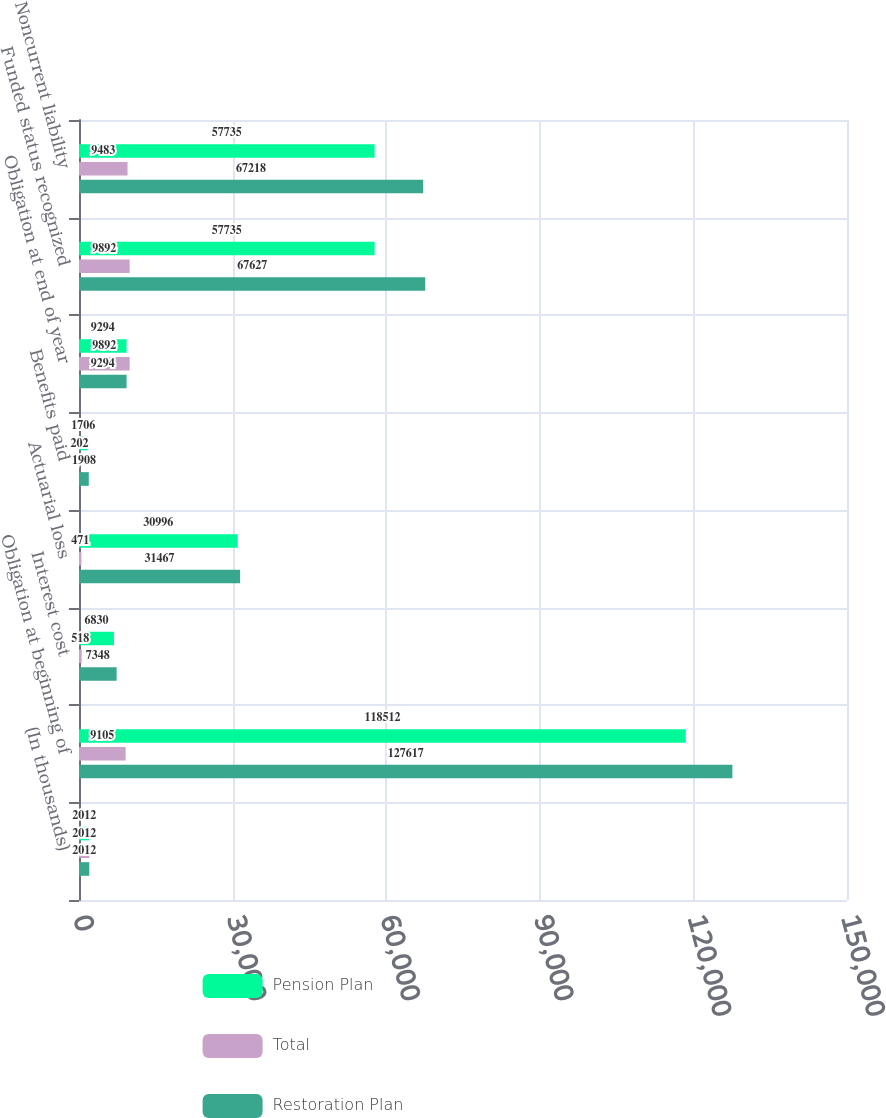Convert chart. <chart><loc_0><loc_0><loc_500><loc_500><stacked_bar_chart><ecel><fcel>(In thousands)<fcel>Obligation at beginning of<fcel>Interest cost<fcel>Actuarial loss<fcel>Benefits paid<fcel>Obligation at end of year<fcel>Funded status recognized<fcel>Noncurrent liability<nl><fcel>Pension Plan<fcel>2012<fcel>118512<fcel>6830<fcel>30996<fcel>1706<fcel>9294<fcel>57735<fcel>57735<nl><fcel>Total<fcel>2012<fcel>9105<fcel>518<fcel>471<fcel>202<fcel>9892<fcel>9892<fcel>9483<nl><fcel>Restoration Plan<fcel>2012<fcel>127617<fcel>7348<fcel>31467<fcel>1908<fcel>9294<fcel>67627<fcel>67218<nl></chart> 